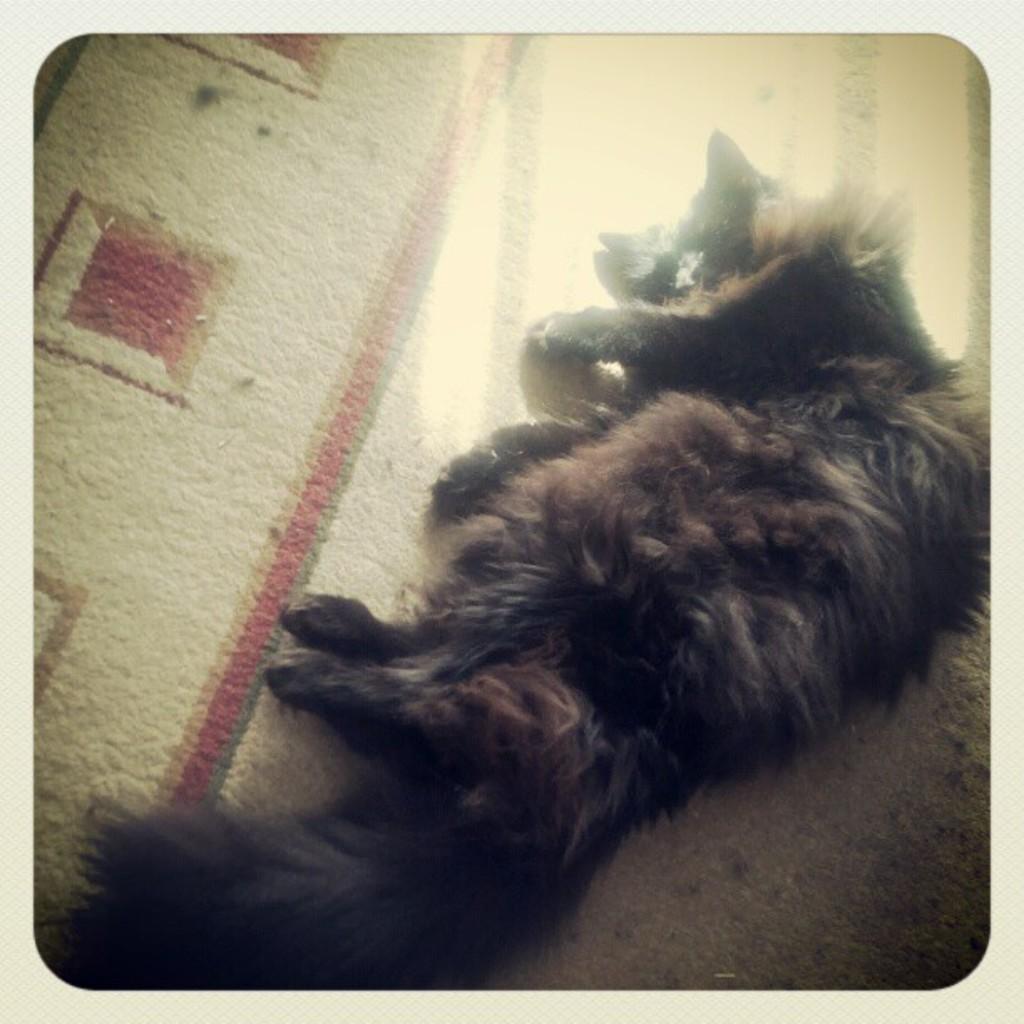Please provide a concise description of this image. In the picture I can see a black color dog is lying on the floor, which is on the right side of the image. Here I can see the sunlight on the carpet. 